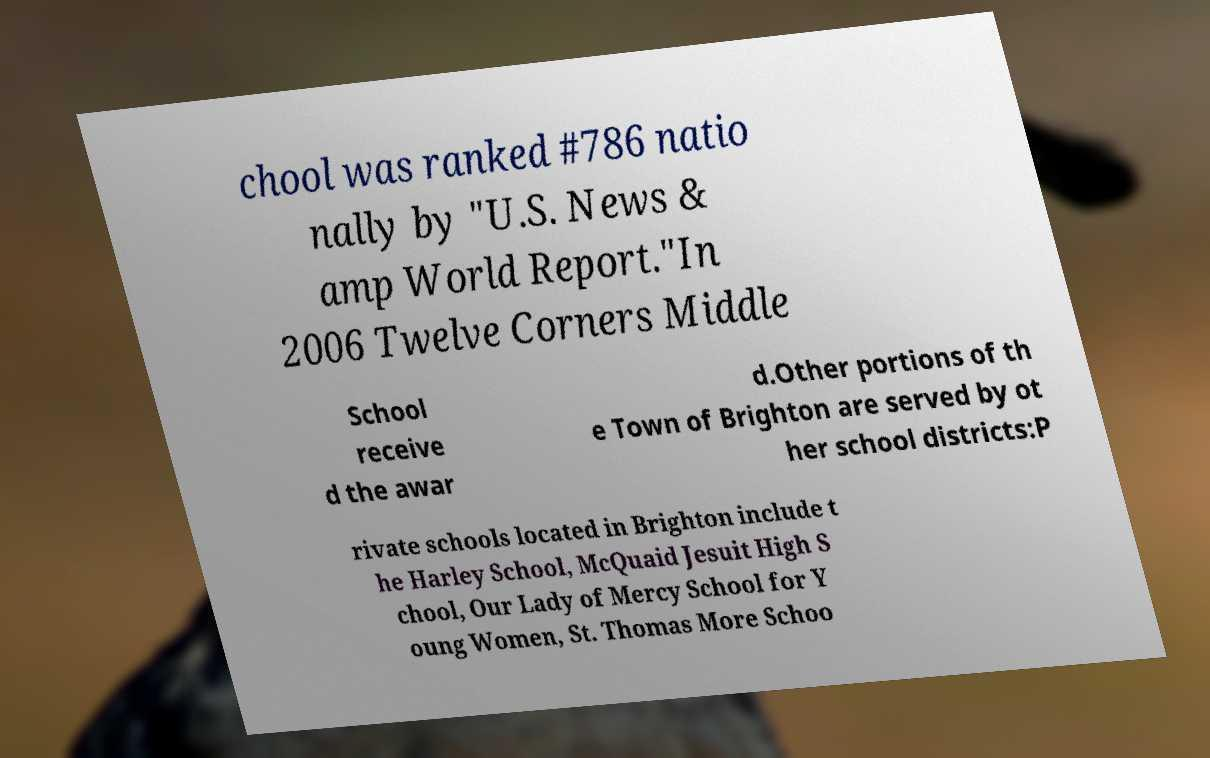Could you extract and type out the text from this image? chool was ranked #786 natio nally by "U.S. News & amp World Report."In 2006 Twelve Corners Middle School receive d the awar d.Other portions of th e Town of Brighton are served by ot her school districts:P rivate schools located in Brighton include t he Harley School, McQuaid Jesuit High S chool, Our Lady of Mercy School for Y oung Women, St. Thomas More Schoo 